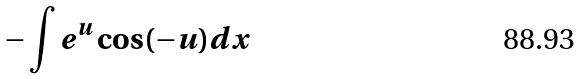<formula> <loc_0><loc_0><loc_500><loc_500>- \int e ^ { u } \cos ( - u ) d x</formula> 